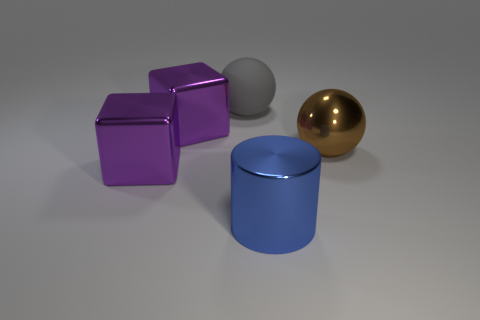There is a big shiny object on the right side of the blue cylinder; is its shape the same as the big matte thing on the left side of the large blue object? yes 